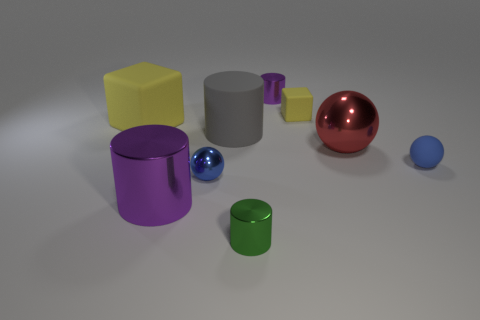Is the number of purple cylinders less than the number of small purple cylinders?
Your answer should be compact. No. Are there any big balls made of the same material as the tiny purple cylinder?
Ensure brevity in your answer.  Yes. Do the small purple object and the tiny green metallic thing that is to the left of the tiny purple metal thing have the same shape?
Your response must be concise. Yes. There is a large metallic cylinder; are there any green cylinders to the right of it?
Your response must be concise. Yes. How many large yellow matte objects have the same shape as the large red metal thing?
Provide a succinct answer. 0. Is the material of the large sphere the same as the purple object behind the big purple object?
Offer a terse response. Yes. What number of green matte spheres are there?
Provide a succinct answer. 0. There is a yellow matte thing that is right of the tiny blue metal thing; what is its size?
Offer a terse response. Small. What number of purple rubber spheres are the same size as the blue metal thing?
Provide a short and direct response. 0. What is the material of the cylinder that is both in front of the gray matte cylinder and on the right side of the large gray rubber cylinder?
Offer a terse response. Metal. 